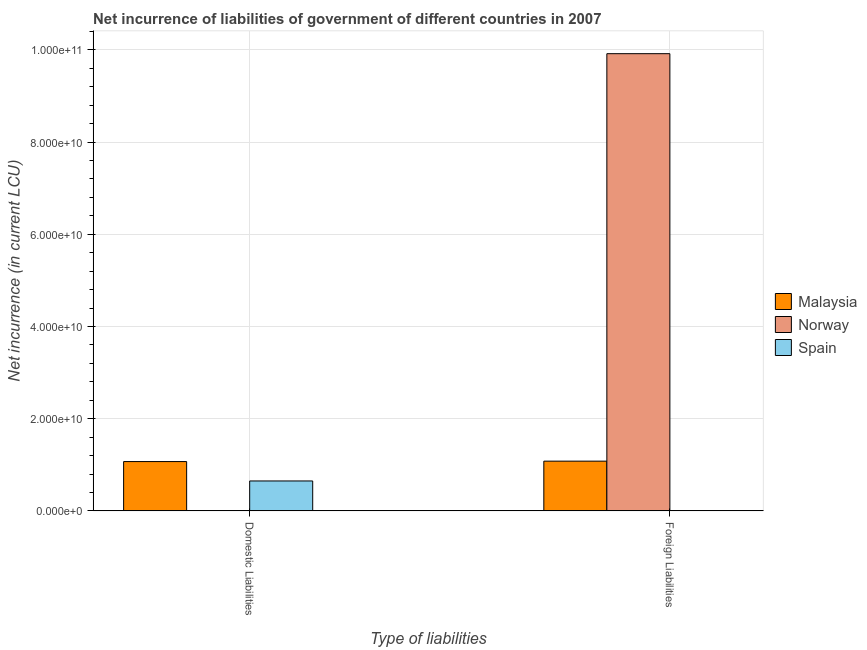How many groups of bars are there?
Provide a succinct answer. 2. How many bars are there on the 1st tick from the left?
Offer a very short reply. 2. What is the label of the 2nd group of bars from the left?
Your response must be concise. Foreign Liabilities. Across all countries, what is the maximum net incurrence of foreign liabilities?
Make the answer very short. 9.92e+1. Across all countries, what is the minimum net incurrence of domestic liabilities?
Offer a very short reply. 0. What is the total net incurrence of domestic liabilities in the graph?
Make the answer very short. 1.72e+1. What is the difference between the net incurrence of foreign liabilities in Malaysia and that in Norway?
Offer a very short reply. -8.84e+1. What is the difference between the net incurrence of domestic liabilities in Malaysia and the net incurrence of foreign liabilities in Spain?
Provide a short and direct response. 1.07e+1. What is the average net incurrence of foreign liabilities per country?
Provide a succinct answer. 3.67e+1. What is the difference between the net incurrence of foreign liabilities and net incurrence of domestic liabilities in Malaysia?
Ensure brevity in your answer.  9.14e+07. In how many countries, is the net incurrence of foreign liabilities greater than 88000000000 LCU?
Offer a very short reply. 1. What is the ratio of the net incurrence of foreign liabilities in Malaysia to that in Norway?
Provide a succinct answer. 0.11. Is the net incurrence of domestic liabilities in Spain less than that in Malaysia?
Ensure brevity in your answer.  Yes. In how many countries, is the net incurrence of foreign liabilities greater than the average net incurrence of foreign liabilities taken over all countries?
Provide a succinct answer. 1. How many bars are there?
Give a very brief answer. 4. Are all the bars in the graph horizontal?
Offer a very short reply. No. How many countries are there in the graph?
Make the answer very short. 3. What is the difference between two consecutive major ticks on the Y-axis?
Your answer should be very brief. 2.00e+1. Does the graph contain grids?
Your answer should be compact. Yes. What is the title of the graph?
Keep it short and to the point. Net incurrence of liabilities of government of different countries in 2007. What is the label or title of the X-axis?
Offer a very short reply. Type of liabilities. What is the label or title of the Y-axis?
Make the answer very short. Net incurrence (in current LCU). What is the Net incurrence (in current LCU) in Malaysia in Domestic Liabilities?
Offer a terse response. 1.07e+1. What is the Net incurrence (in current LCU) in Spain in Domestic Liabilities?
Your response must be concise. 6.49e+09. What is the Net incurrence (in current LCU) in Malaysia in Foreign Liabilities?
Your answer should be very brief. 1.08e+1. What is the Net incurrence (in current LCU) of Norway in Foreign Liabilities?
Your answer should be compact. 9.92e+1. What is the Net incurrence (in current LCU) in Spain in Foreign Liabilities?
Offer a very short reply. 0. Across all Type of liabilities, what is the maximum Net incurrence (in current LCU) in Malaysia?
Ensure brevity in your answer.  1.08e+1. Across all Type of liabilities, what is the maximum Net incurrence (in current LCU) of Norway?
Ensure brevity in your answer.  9.92e+1. Across all Type of liabilities, what is the maximum Net incurrence (in current LCU) of Spain?
Ensure brevity in your answer.  6.49e+09. Across all Type of liabilities, what is the minimum Net incurrence (in current LCU) in Malaysia?
Offer a terse response. 1.07e+1. Across all Type of liabilities, what is the minimum Net incurrence (in current LCU) of Norway?
Your answer should be very brief. 0. What is the total Net incurrence (in current LCU) of Malaysia in the graph?
Provide a succinct answer. 2.15e+1. What is the total Net incurrence (in current LCU) of Norway in the graph?
Your answer should be very brief. 9.92e+1. What is the total Net incurrence (in current LCU) in Spain in the graph?
Your answer should be very brief. 6.49e+09. What is the difference between the Net incurrence (in current LCU) of Malaysia in Domestic Liabilities and that in Foreign Liabilities?
Make the answer very short. -9.14e+07. What is the difference between the Net incurrence (in current LCU) in Malaysia in Domestic Liabilities and the Net incurrence (in current LCU) in Norway in Foreign Liabilities?
Provide a short and direct response. -8.85e+1. What is the average Net incurrence (in current LCU) of Malaysia per Type of liabilities?
Your answer should be very brief. 1.07e+1. What is the average Net incurrence (in current LCU) of Norway per Type of liabilities?
Provide a succinct answer. 4.96e+1. What is the average Net incurrence (in current LCU) of Spain per Type of liabilities?
Offer a very short reply. 3.25e+09. What is the difference between the Net incurrence (in current LCU) of Malaysia and Net incurrence (in current LCU) of Spain in Domestic Liabilities?
Ensure brevity in your answer.  4.20e+09. What is the difference between the Net incurrence (in current LCU) in Malaysia and Net incurrence (in current LCU) in Norway in Foreign Liabilities?
Your response must be concise. -8.84e+1. What is the difference between the highest and the second highest Net incurrence (in current LCU) of Malaysia?
Provide a succinct answer. 9.14e+07. What is the difference between the highest and the lowest Net incurrence (in current LCU) of Malaysia?
Ensure brevity in your answer.  9.14e+07. What is the difference between the highest and the lowest Net incurrence (in current LCU) of Norway?
Offer a very short reply. 9.92e+1. What is the difference between the highest and the lowest Net incurrence (in current LCU) in Spain?
Your answer should be very brief. 6.49e+09. 